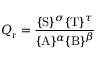Convert formula to latex. <formula><loc_0><loc_0><loc_500><loc_500>Q _ { r } = { \frac { \{ S \} ^ { \sigma } \{ T \} ^ { \tau } } { \{ A \} ^ { \alpha } \{ B \} ^ { \beta } } }</formula> 